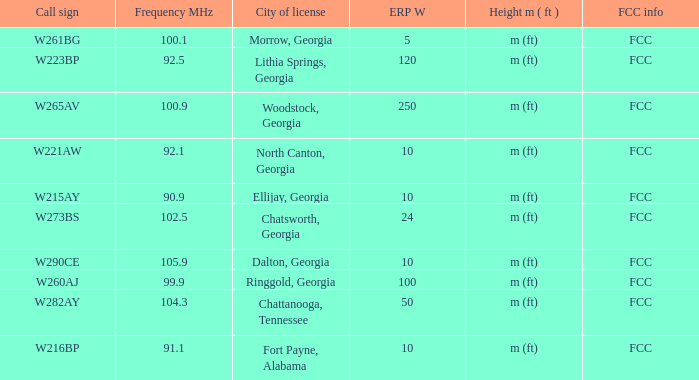How many ERP W is it that has a Call sign of w273bs? 24.0. Could you help me parse every detail presented in this table? {'header': ['Call sign', 'Frequency MHz', 'City of license', 'ERP W', 'Height m ( ft )', 'FCC info'], 'rows': [['W261BG', '100.1', 'Morrow, Georgia', '5', 'm (ft)', 'FCC'], ['W223BP', '92.5', 'Lithia Springs, Georgia', '120', 'm (ft)', 'FCC'], ['W265AV', '100.9', 'Woodstock, Georgia', '250', 'm (ft)', 'FCC'], ['W221AW', '92.1', 'North Canton, Georgia', '10', 'm (ft)', 'FCC'], ['W215AY', '90.9', 'Ellijay, Georgia', '10', 'm (ft)', 'FCC'], ['W273BS', '102.5', 'Chatsworth, Georgia', '24', 'm (ft)', 'FCC'], ['W290CE', '105.9', 'Dalton, Georgia', '10', 'm (ft)', 'FCC'], ['W260AJ', '99.9', 'Ringgold, Georgia', '100', 'm (ft)', 'FCC'], ['W282AY', '104.3', 'Chattanooga, Tennessee', '50', 'm (ft)', 'FCC'], ['W216BP', '91.1', 'Fort Payne, Alabama', '10', 'm (ft)', 'FCC']]} 